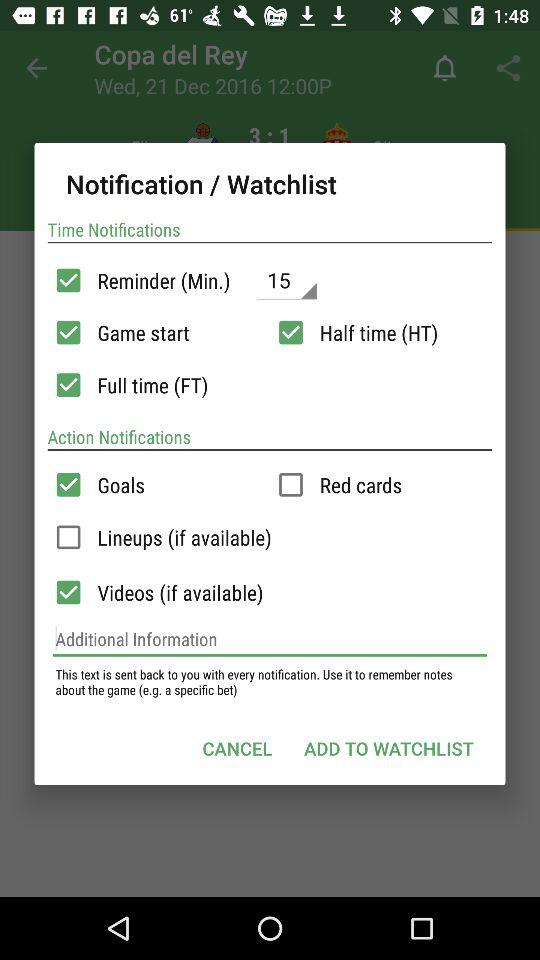Which option is checked in action notifications? The checked options are "Goals" and "Videos (if available)". 